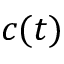Convert formula to latex. <formula><loc_0><loc_0><loc_500><loc_500>c ( t )</formula> 